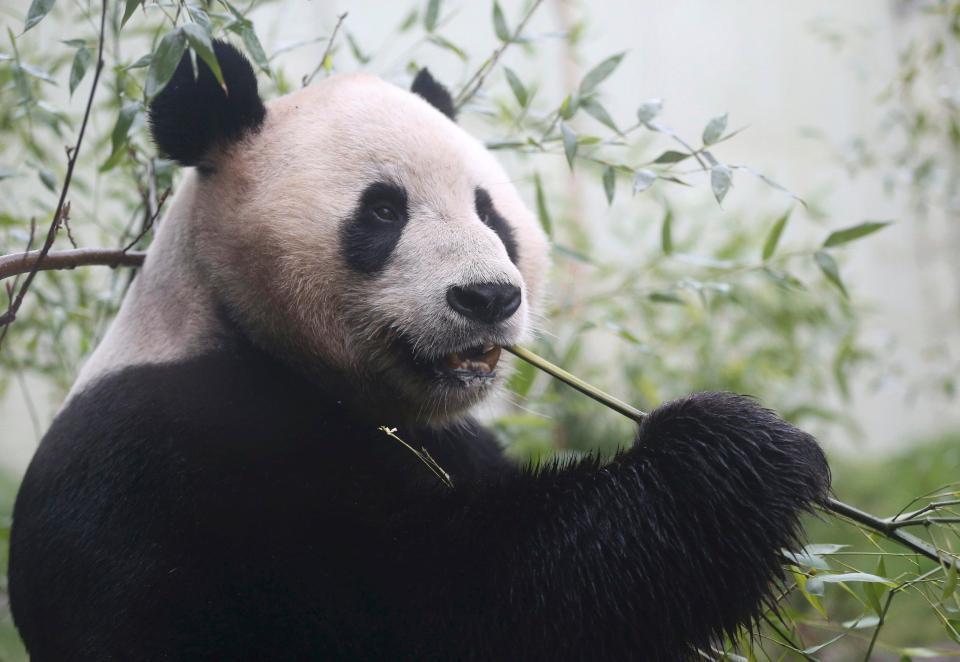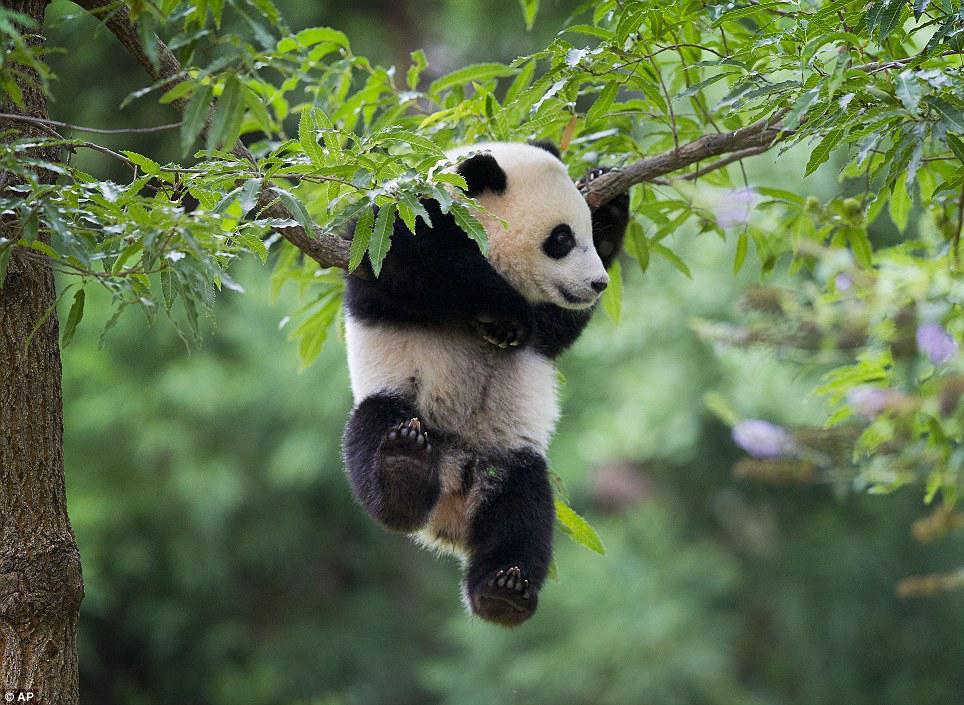The first image is the image on the left, the second image is the image on the right. Evaluate the accuracy of this statement regarding the images: "There is at least one panda up in a tree.". Is it true? Answer yes or no. Yes. The first image is the image on the left, the second image is the image on the right. Examine the images to the left and right. Is the description "Each image contains only one panda, and one image shows a panda with its paws draped over something for support." accurate? Answer yes or no. Yes. 